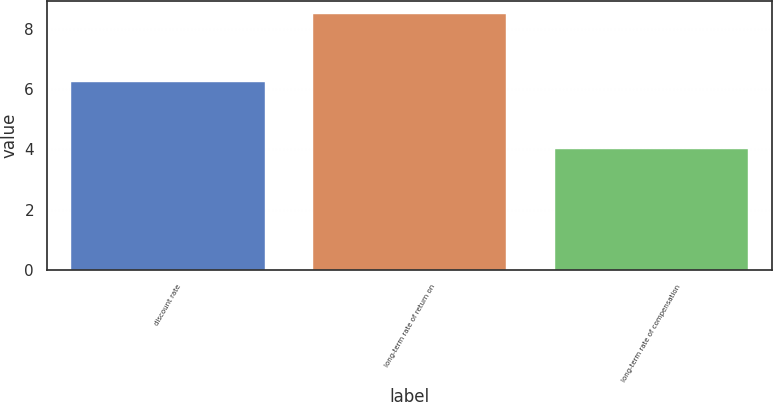Convert chart. <chart><loc_0><loc_0><loc_500><loc_500><bar_chart><fcel>discount rate<fcel>long-term rate of return on<fcel>long-term rate of compensation<nl><fcel>6.25<fcel>8.5<fcel>4<nl></chart> 